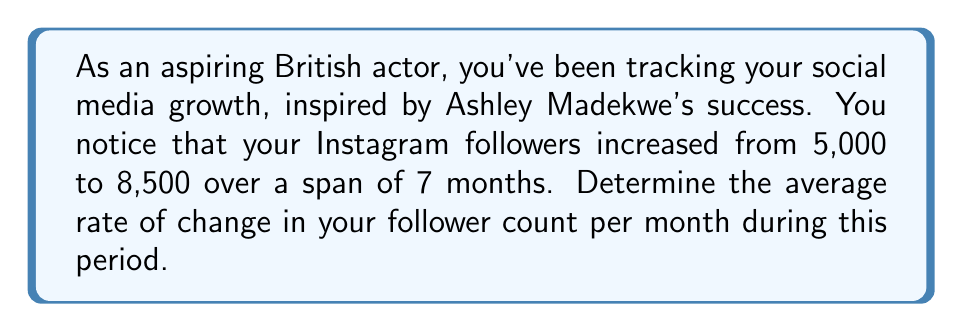Give your solution to this math problem. To solve this problem, we need to use the rate of change formula:

$$ \text{Rate of Change} = \frac{\text{Change in y}}{\text{Change in x}} $$

Where:
- Change in y = Final follower count - Initial follower count
- Change in x = Time period in months

Let's plug in the values:

1. Calculate the change in followers:
   $\text{Change in y} = 8,500 - 5,000 = 3,500$ followers

2. The time period is given as 7 months.

3. Now, let's apply the formula:

   $$ \text{Rate of Change} = \frac{3,500 \text{ followers}}{7 \text{ months}} $$

4. Simplify:
   $$ \text{Rate of Change} = 500 \text{ followers per month} $$

This means that, on average, you gained 500 followers each month during the 7-month period.
Answer: The average rate of change in your follower count is 500 followers per month. 